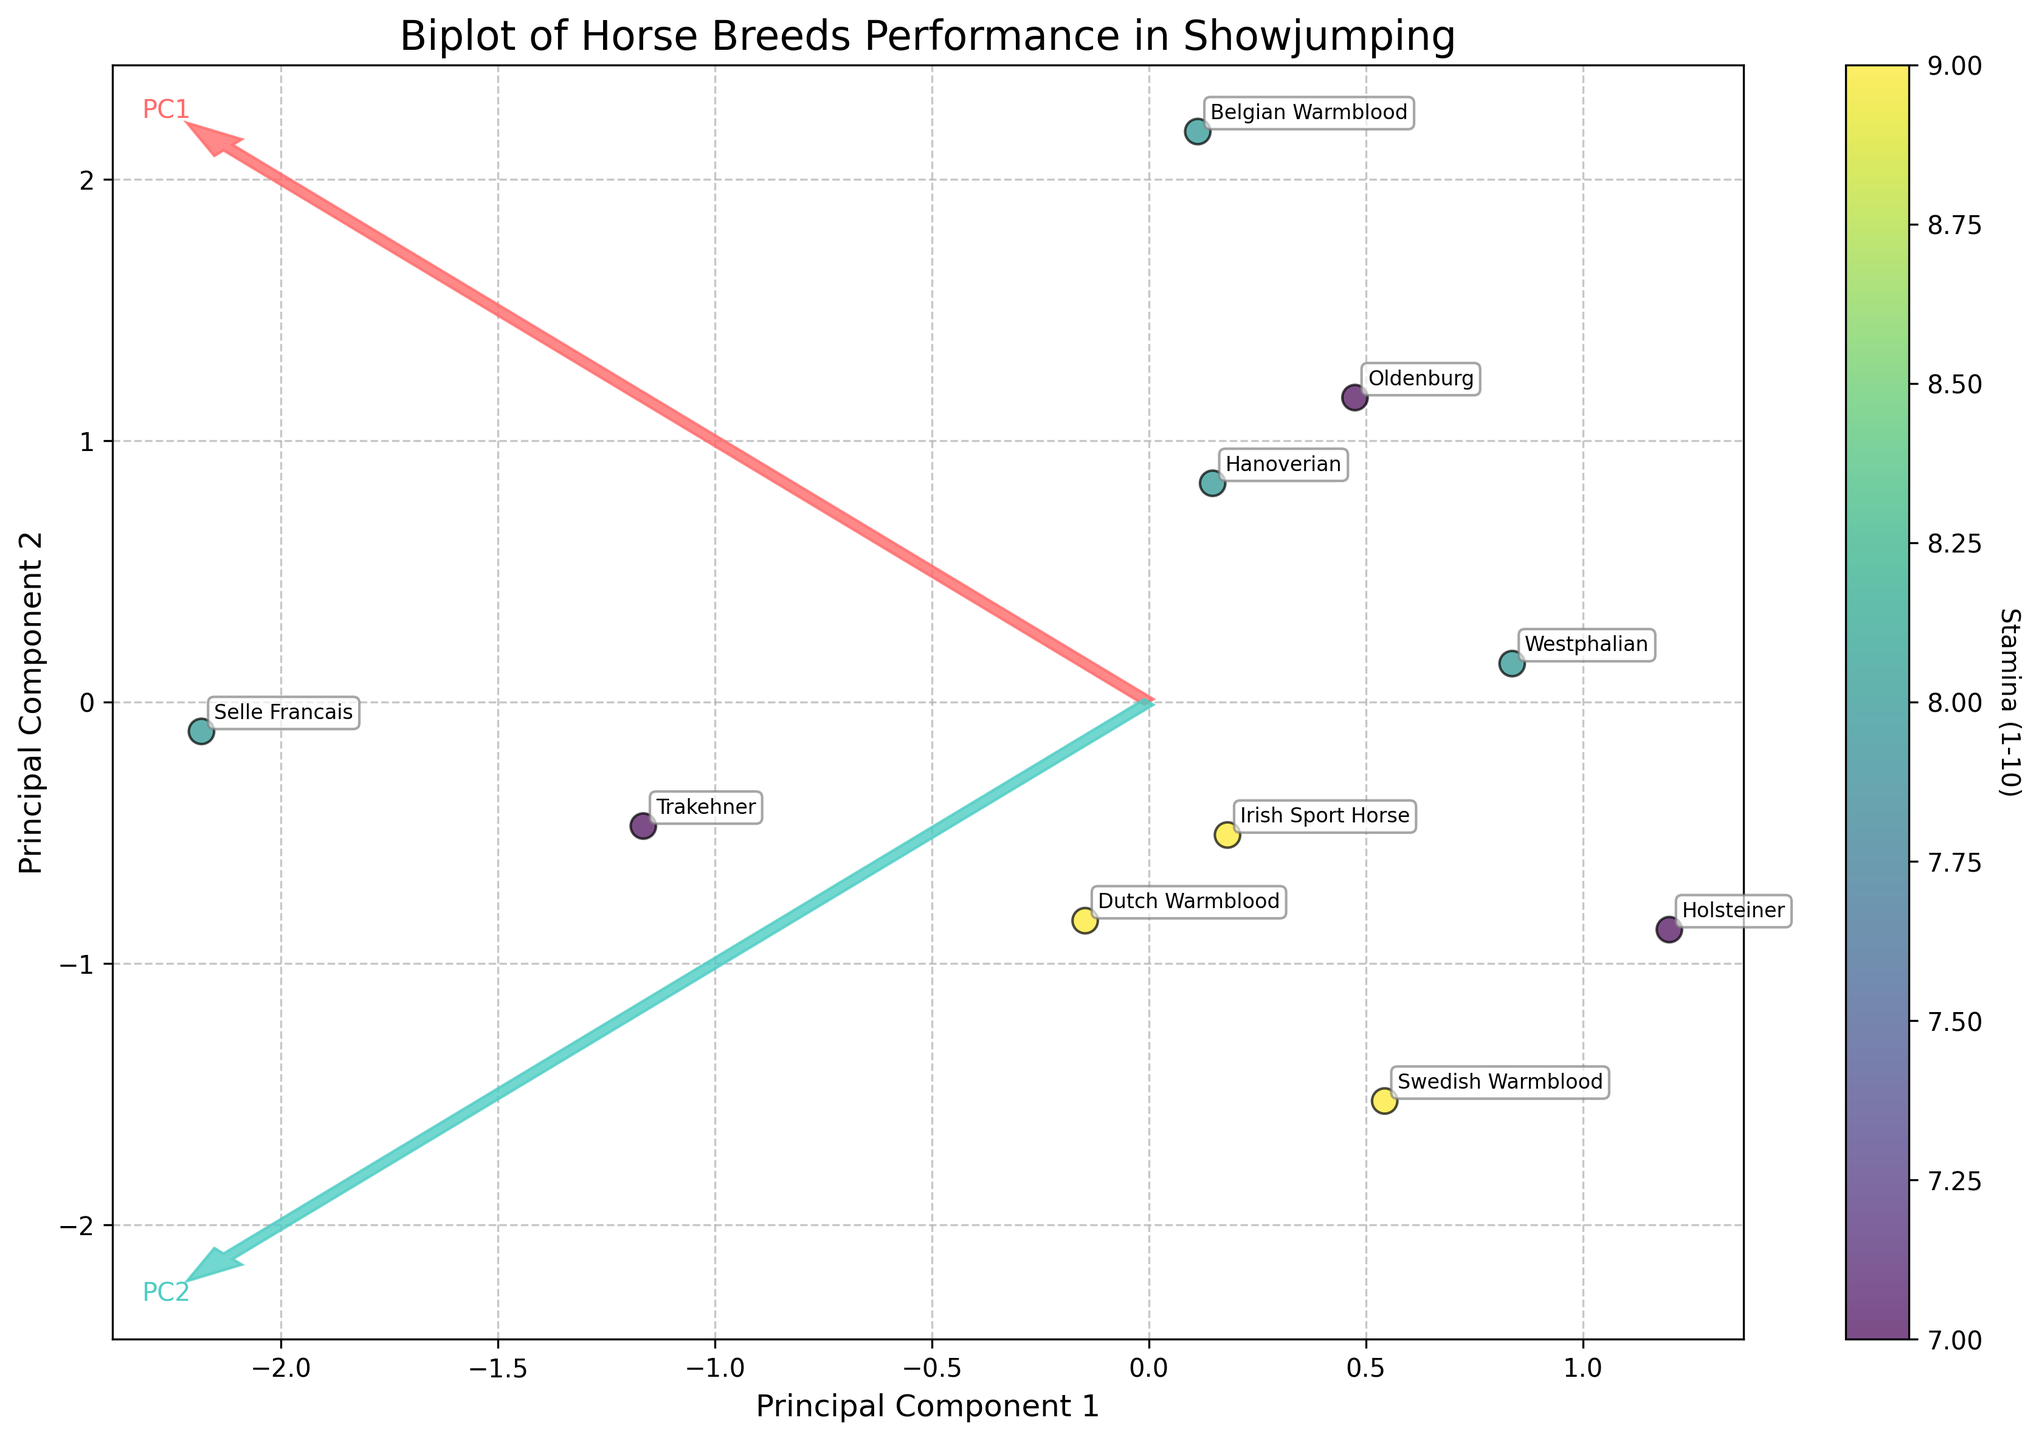What does the color of the data points represent in the figure? The color of the data points is based on the stamina rating for each horse breed. The colors range from light to dark, indicating varying stamina levels from low to high.
Answer: Stamina How many principal components are plotted as arrows in the biplot? The biplot shows two principal components, each represented by an arrow originating from the center. These arrows are labeled as 'PC1' and 'PC2'.
Answer: 2 Which horse breed is positioned closest to the origin (0,0)? The horse breed closest to the origin can be identified by finding the data point nearest to (0,0) on the plot.
Answer: Belgian Warmblood What is the relationship between the direction of the arrows and the performance metrics? The direction of the arrows indicates the contribution of the original performance metrics (Speed and Jump Height) to the principal components. For example, an arrow pointing more horizontally indicates a higher contribution of Speed, while a more vertical arrow indicates a higher contribution of Jump Height.
Answer: Contribution of metrics Which horse breed shows a high value on PC1 but a low value on PC2? A breed with a high value on PC1 but a low value on PC2 will be positioned to the right of the origin and lower on the y-axis in the plot.
Answer: Selle Francais Compare the jumping height and speed of Hanoverian and Dutch Warmblood horses. Which one tends to have a higher speed? By examining the relative positions along the arrow directions, the Dutch Warmblood horse tends to have a higher speed compared to the Hanoverian.
Answer: Dutch Warmblood Which direction does the arrow representing PC2 point in the biplot? The PC2 arrow points more vertically in the biplot, indicating a higher contribution from the Jump Height metric.
Answer: Vertical How does the Stamina level vary with the position on the biplot? The color gradient of the data points shows that Stamina values are distributed across the plot. Higher Stamina levels are generally indicated by darker-colored points.
Answer: Color gradient Which horse breed has the highest value on the PC1 axis? The breed furthest to the right on the PC1 axis represents the highest value on this component.
Answer: Selle Francais Looking at the biplot, what can you infer about the correlation between Speed and Jump Height among horse breeds? Based on the biplot, the relative positions of the arrows and the spread of the data points suggest a proportional relationship between Speed and Jump Height as both metrics contribute to the separation along the principal components.
Answer: Proportional relationship 